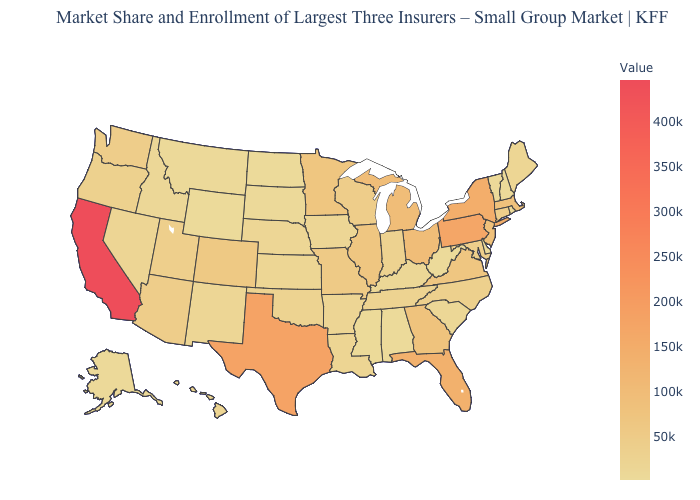Does Massachusetts have the lowest value in the USA?
Write a very short answer. No. Which states have the lowest value in the USA?
Quick response, please. North Dakota. Among the states that border West Virginia , does Pennsylvania have the highest value?
Be succinct. Yes. Does Wyoming have the lowest value in the West?
Write a very short answer. Yes. Among the states that border South Carolina , does North Carolina have the lowest value?
Write a very short answer. Yes. 